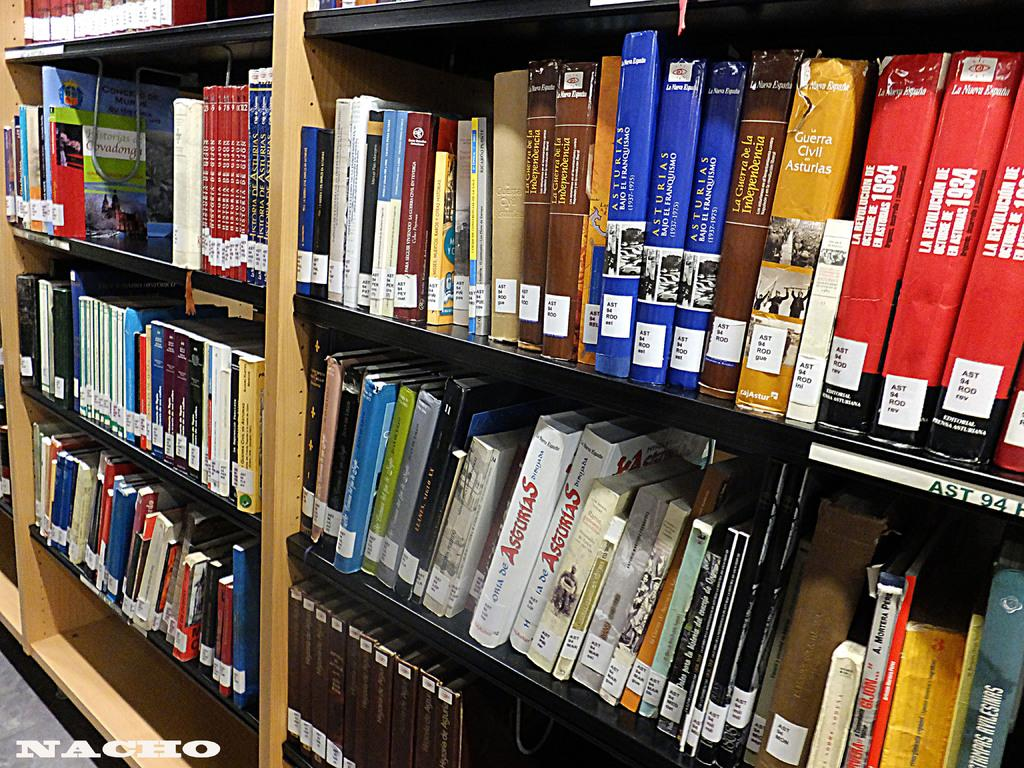<image>
Summarize the visual content of the image. Three copies of a tall blue book titled Asturias sit on a library shelf. 